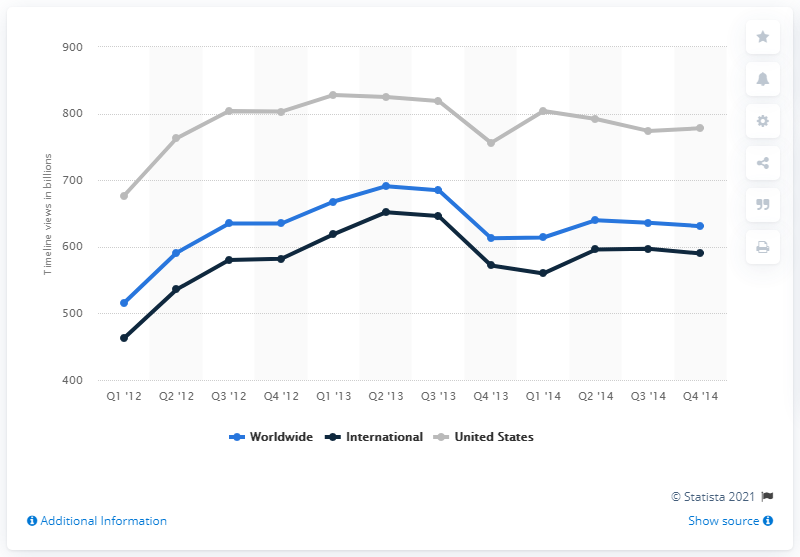Point out several critical features in this image. In the fourth quarter of 2014, the average number of timeline views per monthly active user in the United States was 778. 